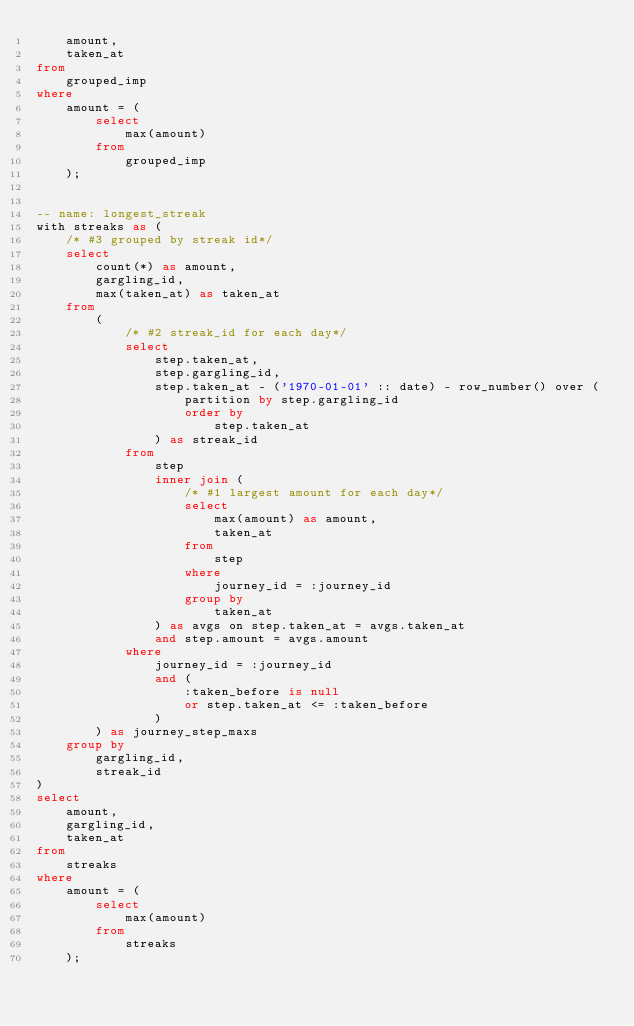<code> <loc_0><loc_0><loc_500><loc_500><_SQL_>    amount,
    taken_at
from
    grouped_imp
where
    amount = (
        select
            max(amount)
        from
            grouped_imp
    );


-- name: longest_streak
with streaks as (
    /* #3 grouped by streak id*/
    select
        count(*) as amount,
        gargling_id,
        max(taken_at) as taken_at
    from
        (
            /* #2 streak_id for each day*/
            select
                step.taken_at,
                step.gargling_id,
                step.taken_at - ('1970-01-01' :: date) - row_number() over (
                    partition by step.gargling_id
                    order by
                        step.taken_at
                ) as streak_id
            from
                step
                inner join (
                    /* #1 largest amount for each day*/
                    select
                        max(amount) as amount,
                        taken_at
                    from
                        step
                    where
                        journey_id = :journey_id
                    group by
                        taken_at
                ) as avgs on step.taken_at = avgs.taken_at
                and step.amount = avgs.amount
            where
                journey_id = :journey_id
                and (
                    :taken_before is null
                    or step.taken_at <= :taken_before
                )
        ) as journey_step_maxs
    group by
        gargling_id,
        streak_id
)
select
    amount,
    gargling_id,
    taken_at
from
    streaks
where
    amount = (
        select
            max(amount)
        from
            streaks
    );
</code> 